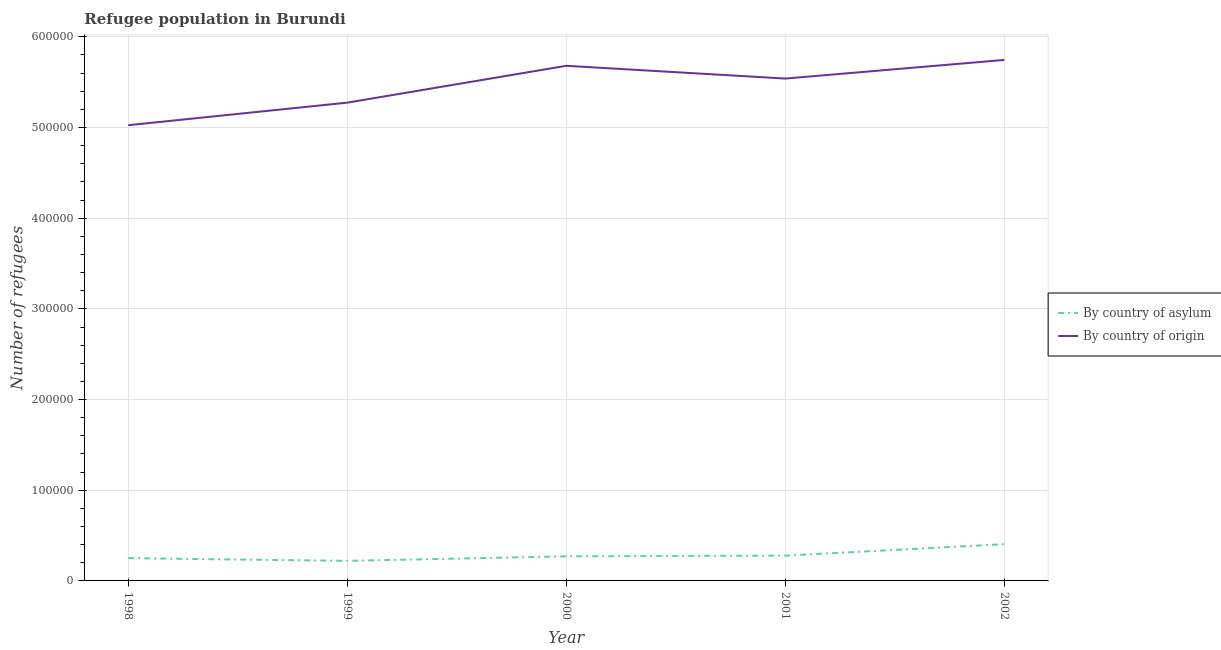What is the number of refugees by country of asylum in 1998?
Provide a short and direct response. 2.51e+04. Across all years, what is the maximum number of refugees by country of asylum?
Keep it short and to the point. 4.05e+04. Across all years, what is the minimum number of refugees by country of asylum?
Offer a terse response. 2.21e+04. In which year was the number of refugees by country of origin minimum?
Your answer should be compact. 1998. What is the total number of refugees by country of asylum in the graph?
Your answer should be very brief. 1.43e+05. What is the difference between the number of refugees by country of origin in 1999 and that in 2002?
Your response must be concise. -4.71e+04. What is the difference between the number of refugees by country of origin in 1998 and the number of refugees by country of asylum in 2002?
Keep it short and to the point. 4.62e+05. What is the average number of refugees by country of asylum per year?
Your answer should be very brief. 2.86e+04. In the year 2000, what is the difference between the number of refugees by country of origin and number of refugees by country of asylum?
Offer a very short reply. 5.41e+05. In how many years, is the number of refugees by country of asylum greater than 320000?
Offer a terse response. 0. What is the ratio of the number of refugees by country of asylum in 2001 to that in 2002?
Provide a short and direct response. 0.69. Is the number of refugees by country of origin in 2000 less than that in 2001?
Provide a succinct answer. No. What is the difference between the highest and the second highest number of refugees by country of origin?
Your answer should be compact. 6473. What is the difference between the highest and the lowest number of refugees by country of asylum?
Give a very brief answer. 1.84e+04. In how many years, is the number of refugees by country of asylum greater than the average number of refugees by country of asylum taken over all years?
Provide a short and direct response. 1. Does the number of refugees by country of origin monotonically increase over the years?
Your answer should be very brief. No. How many lines are there?
Offer a very short reply. 2. How many years are there in the graph?
Make the answer very short. 5. What is the difference between two consecutive major ticks on the Y-axis?
Ensure brevity in your answer.  1.00e+05. Are the values on the major ticks of Y-axis written in scientific E-notation?
Give a very brief answer. No. Does the graph contain any zero values?
Ensure brevity in your answer.  No. Where does the legend appear in the graph?
Your answer should be very brief. Center right. How many legend labels are there?
Provide a succinct answer. 2. How are the legend labels stacked?
Provide a succinct answer. Vertical. What is the title of the graph?
Offer a terse response. Refugee population in Burundi. Does "Primary income" appear as one of the legend labels in the graph?
Your answer should be compact. No. What is the label or title of the X-axis?
Offer a very short reply. Year. What is the label or title of the Y-axis?
Provide a short and direct response. Number of refugees. What is the Number of refugees in By country of asylum in 1998?
Offer a very short reply. 2.51e+04. What is the Number of refugees of By country of origin in 1998?
Your response must be concise. 5.03e+05. What is the Number of refugees in By country of asylum in 1999?
Offer a terse response. 2.21e+04. What is the Number of refugees in By country of origin in 1999?
Keep it short and to the point. 5.27e+05. What is the Number of refugees of By country of asylum in 2000?
Keep it short and to the point. 2.71e+04. What is the Number of refugees of By country of origin in 2000?
Give a very brief answer. 5.68e+05. What is the Number of refugees in By country of asylum in 2001?
Your answer should be very brief. 2.79e+04. What is the Number of refugees of By country of origin in 2001?
Offer a very short reply. 5.54e+05. What is the Number of refugees of By country of asylum in 2002?
Give a very brief answer. 4.05e+04. What is the Number of refugees of By country of origin in 2002?
Give a very brief answer. 5.75e+05. Across all years, what is the maximum Number of refugees in By country of asylum?
Ensure brevity in your answer.  4.05e+04. Across all years, what is the maximum Number of refugees in By country of origin?
Your answer should be very brief. 5.75e+05. Across all years, what is the minimum Number of refugees in By country of asylum?
Give a very brief answer. 2.21e+04. Across all years, what is the minimum Number of refugees in By country of origin?
Provide a succinct answer. 5.03e+05. What is the total Number of refugees in By country of asylum in the graph?
Offer a terse response. 1.43e+05. What is the total Number of refugees of By country of origin in the graph?
Offer a very short reply. 2.73e+06. What is the difference between the Number of refugees of By country of asylum in 1998 and that in 1999?
Provide a short and direct response. 2984. What is the difference between the Number of refugees of By country of origin in 1998 and that in 1999?
Provide a short and direct response. -2.49e+04. What is the difference between the Number of refugees in By country of asylum in 1998 and that in 2000?
Ensure brevity in your answer.  -2043. What is the difference between the Number of refugees of By country of origin in 1998 and that in 2000?
Your answer should be compact. -6.55e+04. What is the difference between the Number of refugees of By country of asylum in 1998 and that in 2001?
Provide a short and direct response. -2803. What is the difference between the Number of refugees in By country of origin in 1998 and that in 2001?
Ensure brevity in your answer.  -5.14e+04. What is the difference between the Number of refugees of By country of asylum in 1998 and that in 2002?
Your response must be concise. -1.54e+04. What is the difference between the Number of refugees in By country of origin in 1998 and that in 2002?
Provide a succinct answer. -7.20e+04. What is the difference between the Number of refugees of By country of asylum in 1999 and that in 2000?
Ensure brevity in your answer.  -5027. What is the difference between the Number of refugees of By country of origin in 1999 and that in 2000?
Your answer should be compact. -4.06e+04. What is the difference between the Number of refugees in By country of asylum in 1999 and that in 2001?
Make the answer very short. -5787. What is the difference between the Number of refugees of By country of origin in 1999 and that in 2001?
Your answer should be very brief. -2.66e+04. What is the difference between the Number of refugees of By country of asylum in 1999 and that in 2002?
Offer a very short reply. -1.84e+04. What is the difference between the Number of refugees in By country of origin in 1999 and that in 2002?
Make the answer very short. -4.71e+04. What is the difference between the Number of refugees of By country of asylum in 2000 and that in 2001?
Ensure brevity in your answer.  -760. What is the difference between the Number of refugees of By country of origin in 2000 and that in 2001?
Offer a very short reply. 1.41e+04. What is the difference between the Number of refugees of By country of asylum in 2000 and that in 2002?
Give a very brief answer. -1.34e+04. What is the difference between the Number of refugees in By country of origin in 2000 and that in 2002?
Provide a succinct answer. -6473. What is the difference between the Number of refugees of By country of asylum in 2001 and that in 2002?
Provide a succinct answer. -1.26e+04. What is the difference between the Number of refugees of By country of origin in 2001 and that in 2002?
Provide a succinct answer. -2.06e+04. What is the difference between the Number of refugees in By country of asylum in 1998 and the Number of refugees in By country of origin in 1999?
Ensure brevity in your answer.  -5.02e+05. What is the difference between the Number of refugees in By country of asylum in 1998 and the Number of refugees in By country of origin in 2000?
Provide a short and direct response. -5.43e+05. What is the difference between the Number of refugees of By country of asylum in 1998 and the Number of refugees of By country of origin in 2001?
Provide a short and direct response. -5.29e+05. What is the difference between the Number of refugees in By country of asylum in 1998 and the Number of refugees in By country of origin in 2002?
Keep it short and to the point. -5.49e+05. What is the difference between the Number of refugees of By country of asylum in 1999 and the Number of refugees of By country of origin in 2000?
Offer a terse response. -5.46e+05. What is the difference between the Number of refugees of By country of asylum in 1999 and the Number of refugees of By country of origin in 2001?
Keep it short and to the point. -5.32e+05. What is the difference between the Number of refugees in By country of asylum in 1999 and the Number of refugees in By country of origin in 2002?
Make the answer very short. -5.52e+05. What is the difference between the Number of refugees of By country of asylum in 2000 and the Number of refugees of By country of origin in 2001?
Offer a terse response. -5.27e+05. What is the difference between the Number of refugees in By country of asylum in 2000 and the Number of refugees in By country of origin in 2002?
Provide a succinct answer. -5.47e+05. What is the difference between the Number of refugees of By country of asylum in 2001 and the Number of refugees of By country of origin in 2002?
Your answer should be compact. -5.47e+05. What is the average Number of refugees of By country of asylum per year?
Give a very brief answer. 2.86e+04. What is the average Number of refugees in By country of origin per year?
Offer a very short reply. 5.45e+05. In the year 1998, what is the difference between the Number of refugees of By country of asylum and Number of refugees of By country of origin?
Provide a short and direct response. -4.77e+05. In the year 1999, what is the difference between the Number of refugees of By country of asylum and Number of refugees of By country of origin?
Provide a succinct answer. -5.05e+05. In the year 2000, what is the difference between the Number of refugees of By country of asylum and Number of refugees of By country of origin?
Your response must be concise. -5.41e+05. In the year 2001, what is the difference between the Number of refugees in By country of asylum and Number of refugees in By country of origin?
Keep it short and to the point. -5.26e+05. In the year 2002, what is the difference between the Number of refugees of By country of asylum and Number of refugees of By country of origin?
Your answer should be very brief. -5.34e+05. What is the ratio of the Number of refugees in By country of asylum in 1998 to that in 1999?
Provide a short and direct response. 1.14. What is the ratio of the Number of refugees of By country of origin in 1998 to that in 1999?
Offer a terse response. 0.95. What is the ratio of the Number of refugees of By country of asylum in 1998 to that in 2000?
Give a very brief answer. 0.92. What is the ratio of the Number of refugees in By country of origin in 1998 to that in 2000?
Make the answer very short. 0.88. What is the ratio of the Number of refugees in By country of asylum in 1998 to that in 2001?
Offer a very short reply. 0.9. What is the ratio of the Number of refugees in By country of origin in 1998 to that in 2001?
Provide a short and direct response. 0.91. What is the ratio of the Number of refugees of By country of asylum in 1998 to that in 2002?
Make the answer very short. 0.62. What is the ratio of the Number of refugees of By country of origin in 1998 to that in 2002?
Keep it short and to the point. 0.87. What is the ratio of the Number of refugees of By country of asylum in 1999 to that in 2000?
Give a very brief answer. 0.81. What is the ratio of the Number of refugees in By country of origin in 1999 to that in 2000?
Your response must be concise. 0.93. What is the ratio of the Number of refugees of By country of asylum in 1999 to that in 2001?
Your response must be concise. 0.79. What is the ratio of the Number of refugees in By country of origin in 1999 to that in 2001?
Make the answer very short. 0.95. What is the ratio of the Number of refugees in By country of asylum in 1999 to that in 2002?
Offer a terse response. 0.55. What is the ratio of the Number of refugees of By country of origin in 1999 to that in 2002?
Offer a terse response. 0.92. What is the ratio of the Number of refugees of By country of asylum in 2000 to that in 2001?
Give a very brief answer. 0.97. What is the ratio of the Number of refugees in By country of origin in 2000 to that in 2001?
Offer a terse response. 1.03. What is the ratio of the Number of refugees of By country of asylum in 2000 to that in 2002?
Your answer should be very brief. 0.67. What is the ratio of the Number of refugees of By country of origin in 2000 to that in 2002?
Your response must be concise. 0.99. What is the ratio of the Number of refugees of By country of asylum in 2001 to that in 2002?
Offer a very short reply. 0.69. What is the ratio of the Number of refugees of By country of origin in 2001 to that in 2002?
Offer a very short reply. 0.96. What is the difference between the highest and the second highest Number of refugees in By country of asylum?
Make the answer very short. 1.26e+04. What is the difference between the highest and the second highest Number of refugees in By country of origin?
Make the answer very short. 6473. What is the difference between the highest and the lowest Number of refugees in By country of asylum?
Ensure brevity in your answer.  1.84e+04. What is the difference between the highest and the lowest Number of refugees of By country of origin?
Your answer should be compact. 7.20e+04. 